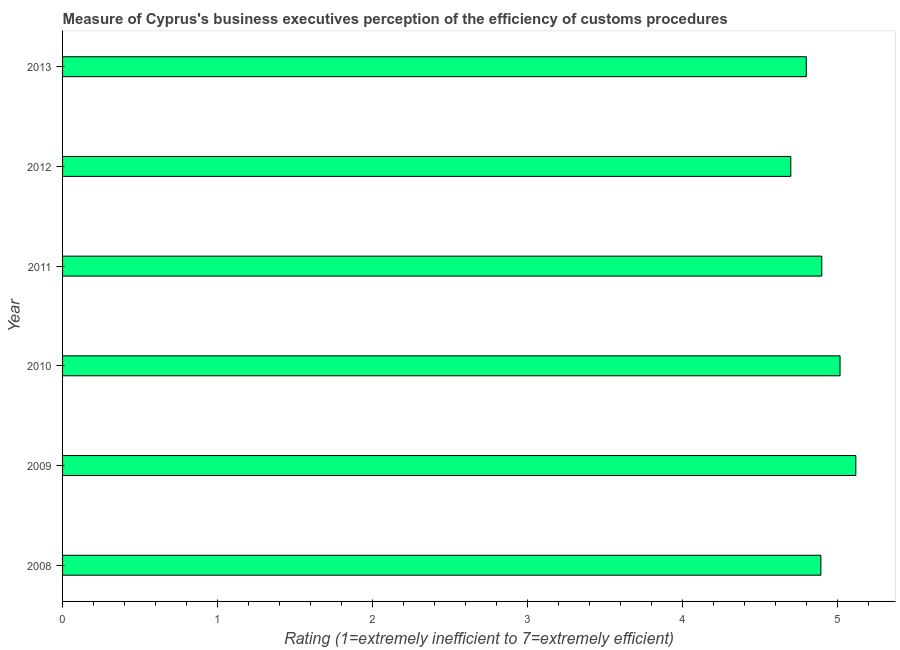What is the title of the graph?
Offer a terse response. Measure of Cyprus's business executives perception of the efficiency of customs procedures. What is the label or title of the X-axis?
Your answer should be very brief. Rating (1=extremely inefficient to 7=extremely efficient). What is the rating measuring burden of customs procedure in 2011?
Provide a short and direct response. 4.9. Across all years, what is the maximum rating measuring burden of customs procedure?
Make the answer very short. 5.12. In which year was the rating measuring burden of customs procedure minimum?
Provide a short and direct response. 2012. What is the sum of the rating measuring burden of customs procedure?
Give a very brief answer. 29.43. What is the difference between the rating measuring burden of customs procedure in 2009 and 2011?
Your response must be concise. 0.22. What is the average rating measuring burden of customs procedure per year?
Offer a terse response. 4.91. What is the median rating measuring burden of customs procedure?
Your answer should be very brief. 4.9. What is the ratio of the rating measuring burden of customs procedure in 2011 to that in 2012?
Your answer should be compact. 1.04. Is the rating measuring burden of customs procedure in 2008 less than that in 2013?
Keep it short and to the point. No. Is the difference between the rating measuring burden of customs procedure in 2009 and 2010 greater than the difference between any two years?
Give a very brief answer. No. What is the difference between the highest and the second highest rating measuring burden of customs procedure?
Offer a terse response. 0.1. What is the difference between the highest and the lowest rating measuring burden of customs procedure?
Give a very brief answer. 0.42. In how many years, is the rating measuring burden of customs procedure greater than the average rating measuring burden of customs procedure taken over all years?
Offer a terse response. 2. How many bars are there?
Your answer should be very brief. 6. What is the difference between two consecutive major ticks on the X-axis?
Offer a very short reply. 1. Are the values on the major ticks of X-axis written in scientific E-notation?
Give a very brief answer. No. What is the Rating (1=extremely inefficient to 7=extremely efficient) of 2008?
Make the answer very short. 4.89. What is the Rating (1=extremely inefficient to 7=extremely efficient) in 2009?
Keep it short and to the point. 5.12. What is the Rating (1=extremely inefficient to 7=extremely efficient) in 2010?
Offer a very short reply. 5.02. What is the Rating (1=extremely inefficient to 7=extremely efficient) of 2011?
Keep it short and to the point. 4.9. What is the Rating (1=extremely inefficient to 7=extremely efficient) of 2012?
Your response must be concise. 4.7. What is the difference between the Rating (1=extremely inefficient to 7=extremely efficient) in 2008 and 2009?
Your answer should be compact. -0.23. What is the difference between the Rating (1=extremely inefficient to 7=extremely efficient) in 2008 and 2010?
Make the answer very short. -0.12. What is the difference between the Rating (1=extremely inefficient to 7=extremely efficient) in 2008 and 2011?
Ensure brevity in your answer.  -0.01. What is the difference between the Rating (1=extremely inefficient to 7=extremely efficient) in 2008 and 2012?
Ensure brevity in your answer.  0.19. What is the difference between the Rating (1=extremely inefficient to 7=extremely efficient) in 2008 and 2013?
Provide a short and direct response. 0.09. What is the difference between the Rating (1=extremely inefficient to 7=extremely efficient) in 2009 and 2010?
Make the answer very short. 0.1. What is the difference between the Rating (1=extremely inefficient to 7=extremely efficient) in 2009 and 2011?
Give a very brief answer. 0.22. What is the difference between the Rating (1=extremely inefficient to 7=extremely efficient) in 2009 and 2012?
Offer a very short reply. 0.42. What is the difference between the Rating (1=extremely inefficient to 7=extremely efficient) in 2009 and 2013?
Provide a succinct answer. 0.32. What is the difference between the Rating (1=extremely inefficient to 7=extremely efficient) in 2010 and 2011?
Offer a terse response. 0.12. What is the difference between the Rating (1=extremely inefficient to 7=extremely efficient) in 2010 and 2012?
Make the answer very short. 0.32. What is the difference between the Rating (1=extremely inefficient to 7=extremely efficient) in 2010 and 2013?
Your response must be concise. 0.22. What is the difference between the Rating (1=extremely inefficient to 7=extremely efficient) in 2011 and 2013?
Give a very brief answer. 0.1. What is the difference between the Rating (1=extremely inefficient to 7=extremely efficient) in 2012 and 2013?
Make the answer very short. -0.1. What is the ratio of the Rating (1=extremely inefficient to 7=extremely efficient) in 2008 to that in 2009?
Your response must be concise. 0.96. What is the ratio of the Rating (1=extremely inefficient to 7=extremely efficient) in 2008 to that in 2012?
Provide a succinct answer. 1.04. What is the ratio of the Rating (1=extremely inefficient to 7=extremely efficient) in 2008 to that in 2013?
Provide a succinct answer. 1.02. What is the ratio of the Rating (1=extremely inefficient to 7=extremely efficient) in 2009 to that in 2011?
Your answer should be very brief. 1.04. What is the ratio of the Rating (1=extremely inefficient to 7=extremely efficient) in 2009 to that in 2012?
Your response must be concise. 1.09. What is the ratio of the Rating (1=extremely inefficient to 7=extremely efficient) in 2009 to that in 2013?
Your answer should be very brief. 1.07. What is the ratio of the Rating (1=extremely inefficient to 7=extremely efficient) in 2010 to that in 2011?
Keep it short and to the point. 1.02. What is the ratio of the Rating (1=extremely inefficient to 7=extremely efficient) in 2010 to that in 2012?
Give a very brief answer. 1.07. What is the ratio of the Rating (1=extremely inefficient to 7=extremely efficient) in 2010 to that in 2013?
Your answer should be compact. 1.04. What is the ratio of the Rating (1=extremely inefficient to 7=extremely efficient) in 2011 to that in 2012?
Provide a short and direct response. 1.04. What is the ratio of the Rating (1=extremely inefficient to 7=extremely efficient) in 2011 to that in 2013?
Your answer should be compact. 1.02. 